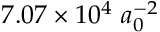Convert formula to latex. <formula><loc_0><loc_0><loc_500><loc_500>7 . 0 7 \times 1 0 ^ { 4 } \ a _ { 0 } ^ { - 2 }</formula> 